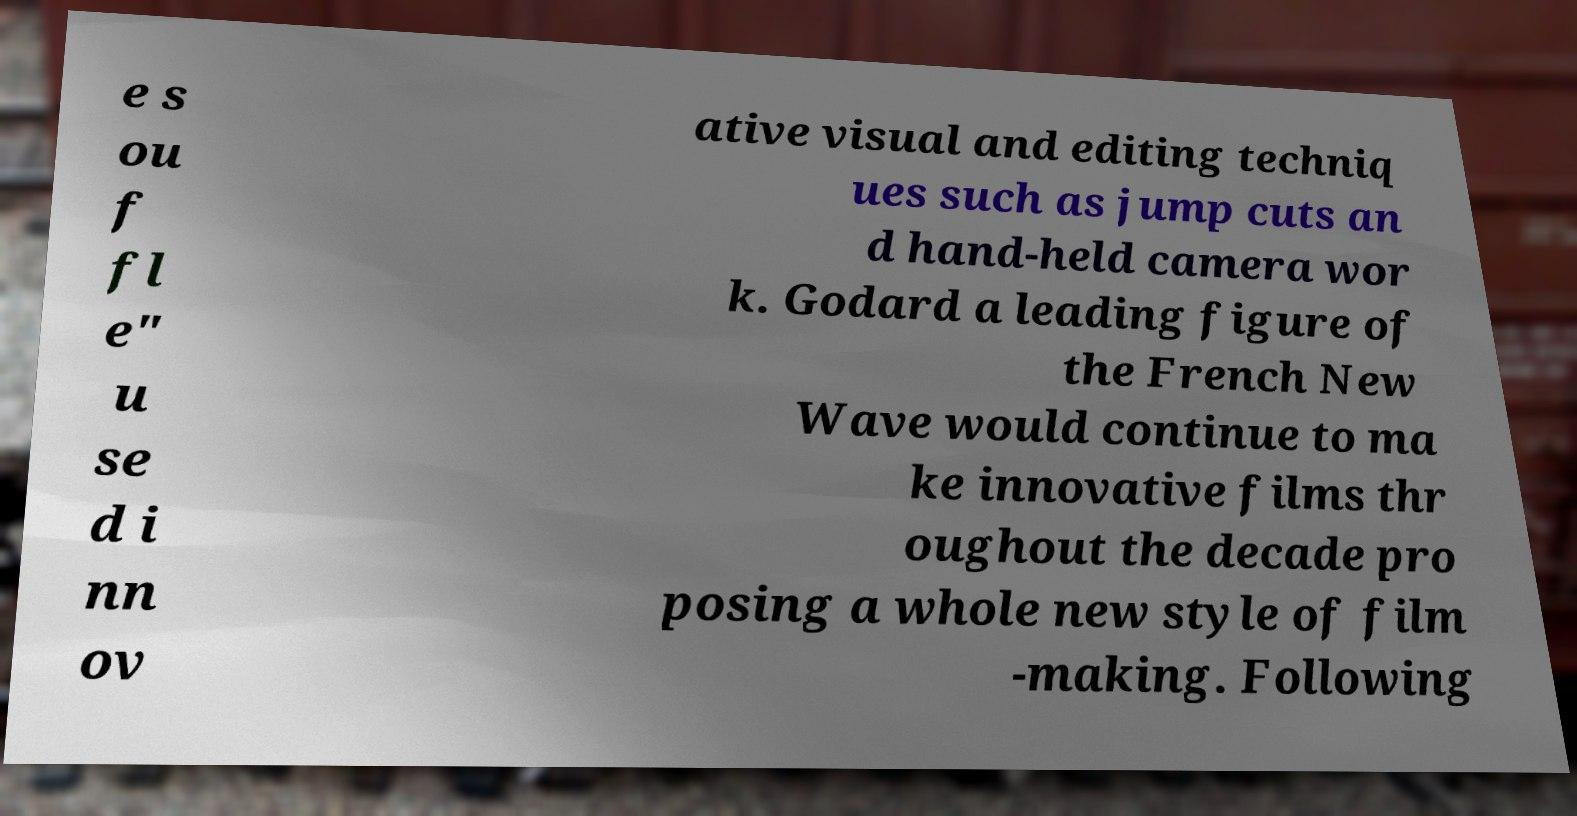There's text embedded in this image that I need extracted. Can you transcribe it verbatim? e s ou f fl e" u se d i nn ov ative visual and editing techniq ues such as jump cuts an d hand-held camera wor k. Godard a leading figure of the French New Wave would continue to ma ke innovative films thr oughout the decade pro posing a whole new style of film -making. Following 